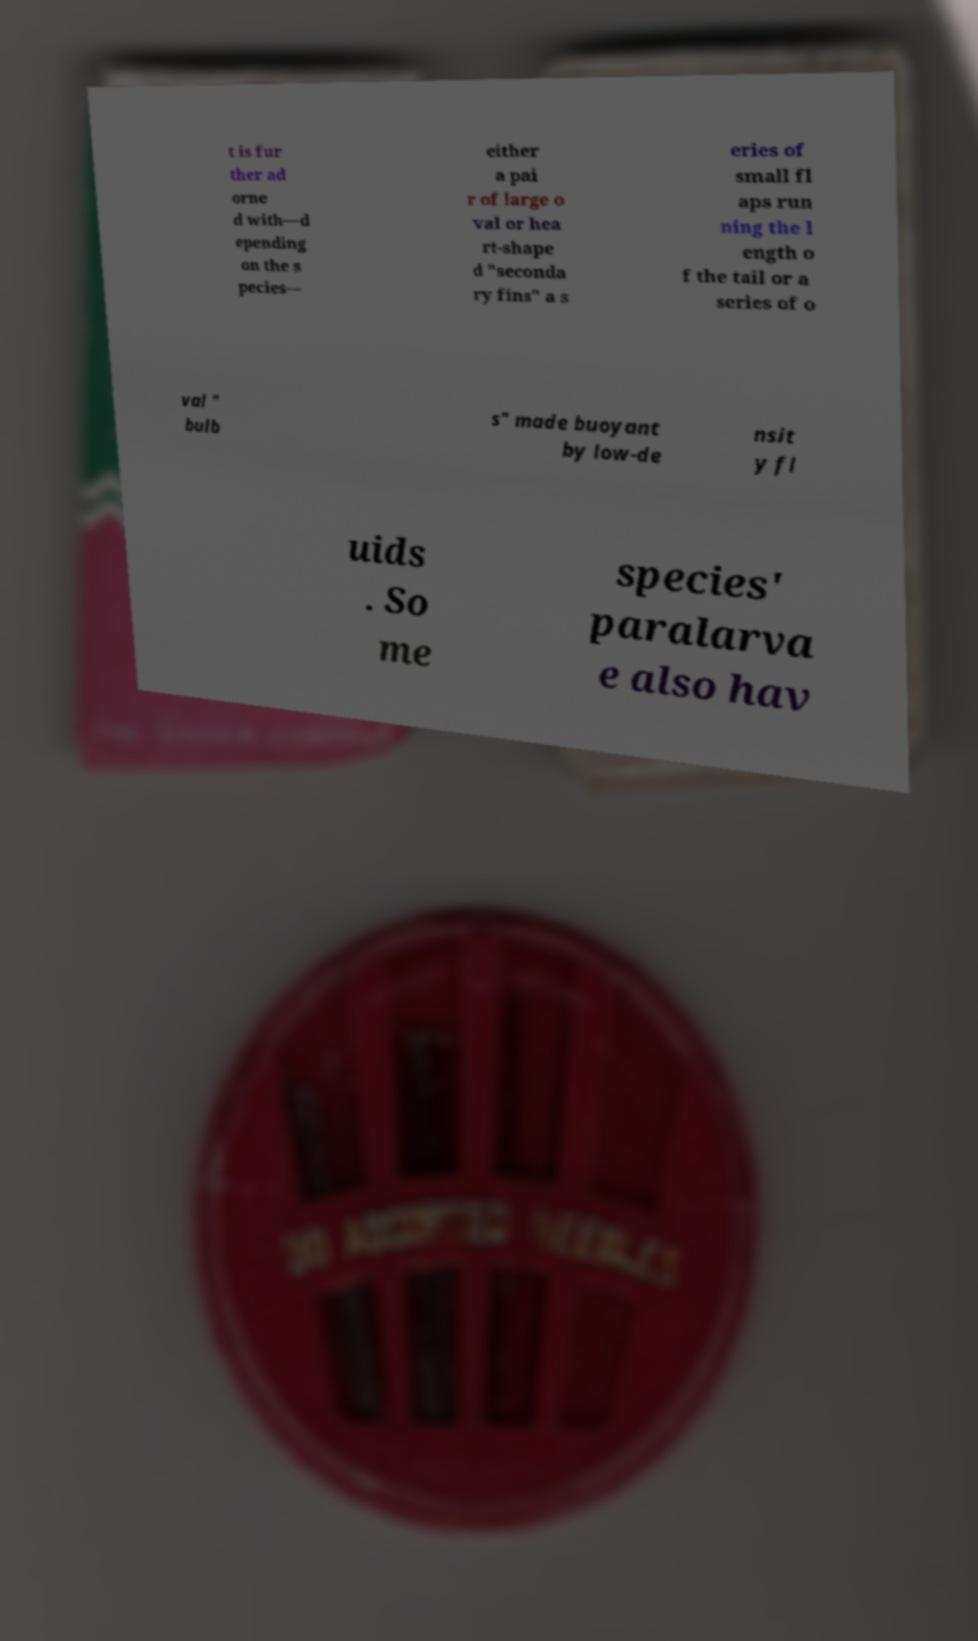Could you extract and type out the text from this image? t is fur ther ad orne d with—d epending on the s pecies— either a pai r of large o val or hea rt-shape d "seconda ry fins" a s eries of small fl aps run ning the l ength o f the tail or a series of o val " bulb s" made buoyant by low-de nsit y fl uids . So me species' paralarva e also hav 